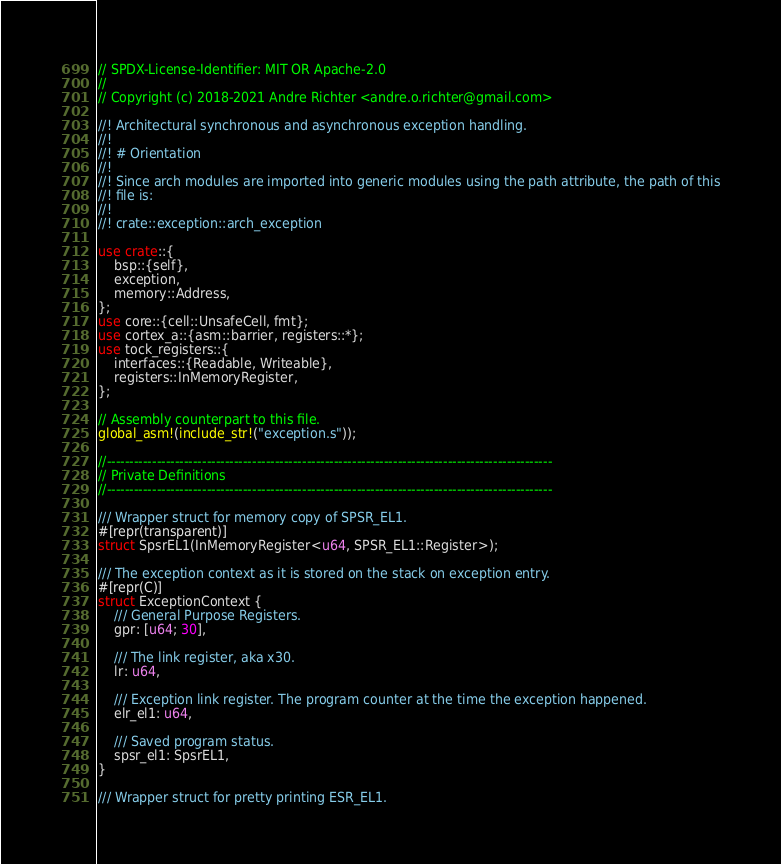<code> <loc_0><loc_0><loc_500><loc_500><_Rust_>// SPDX-License-Identifier: MIT OR Apache-2.0
//
// Copyright (c) 2018-2021 Andre Richter <andre.o.richter@gmail.com>

//! Architectural synchronous and asynchronous exception handling.
//!
//! # Orientation
//!
//! Since arch modules are imported into generic modules using the path attribute, the path of this
//! file is:
//!
//! crate::exception::arch_exception

use crate::{
    bsp::{self},
    exception,
    memory::Address,
};
use core::{cell::UnsafeCell, fmt};
use cortex_a::{asm::barrier, registers::*};
use tock_registers::{
    interfaces::{Readable, Writeable},
    registers::InMemoryRegister,
};

// Assembly counterpart to this file.
global_asm!(include_str!("exception.s"));

//--------------------------------------------------------------------------------------------------
// Private Definitions
//--------------------------------------------------------------------------------------------------

/// Wrapper struct for memory copy of SPSR_EL1.
#[repr(transparent)]
struct SpsrEL1(InMemoryRegister<u64, SPSR_EL1::Register>);

/// The exception context as it is stored on the stack on exception entry.
#[repr(C)]
struct ExceptionContext {
    /// General Purpose Registers.
    gpr: [u64; 30],

    /// The link register, aka x30.
    lr: u64,

    /// Exception link register. The program counter at the time the exception happened.
    elr_el1: u64,

    /// Saved program status.
    spsr_el1: SpsrEL1,
}

/// Wrapper struct for pretty printing ESR_EL1.</code> 